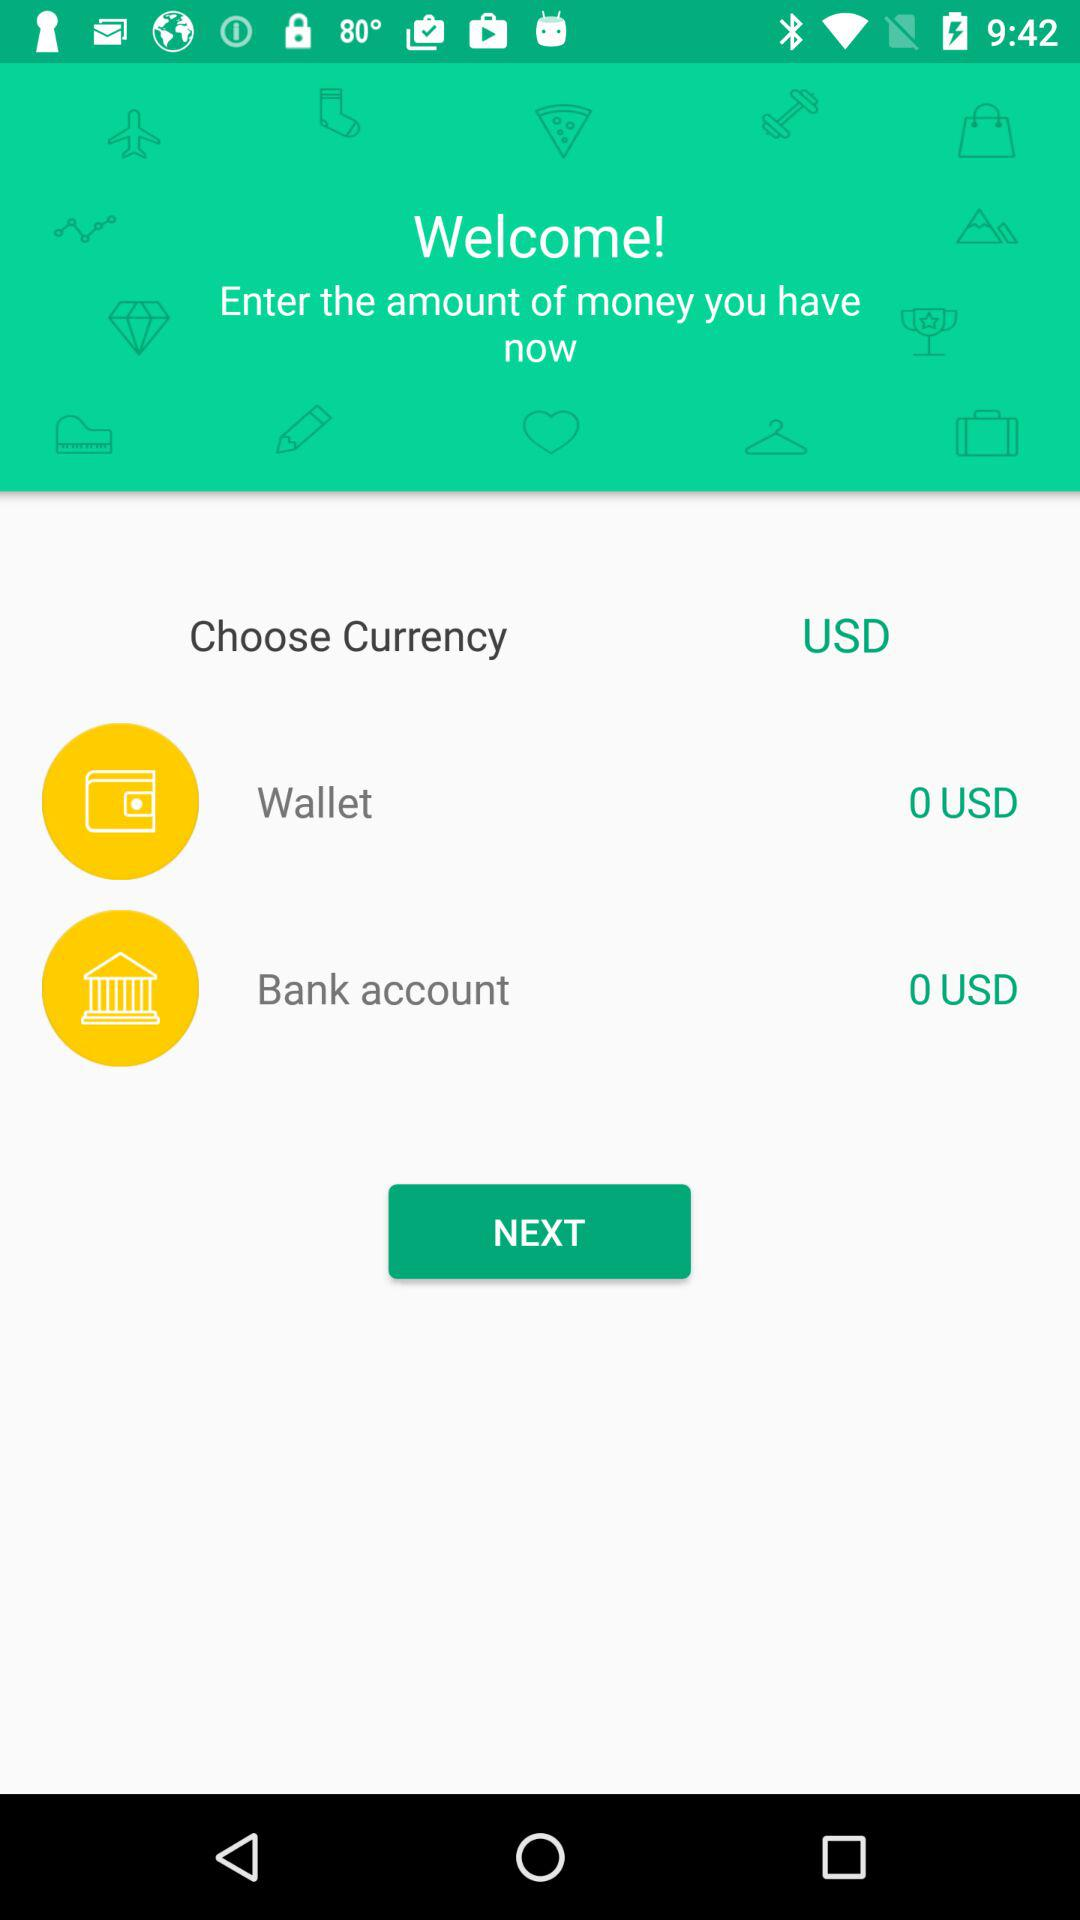How much money do I have in my bank account?
Answer the question using a single word or phrase. 0 USD 